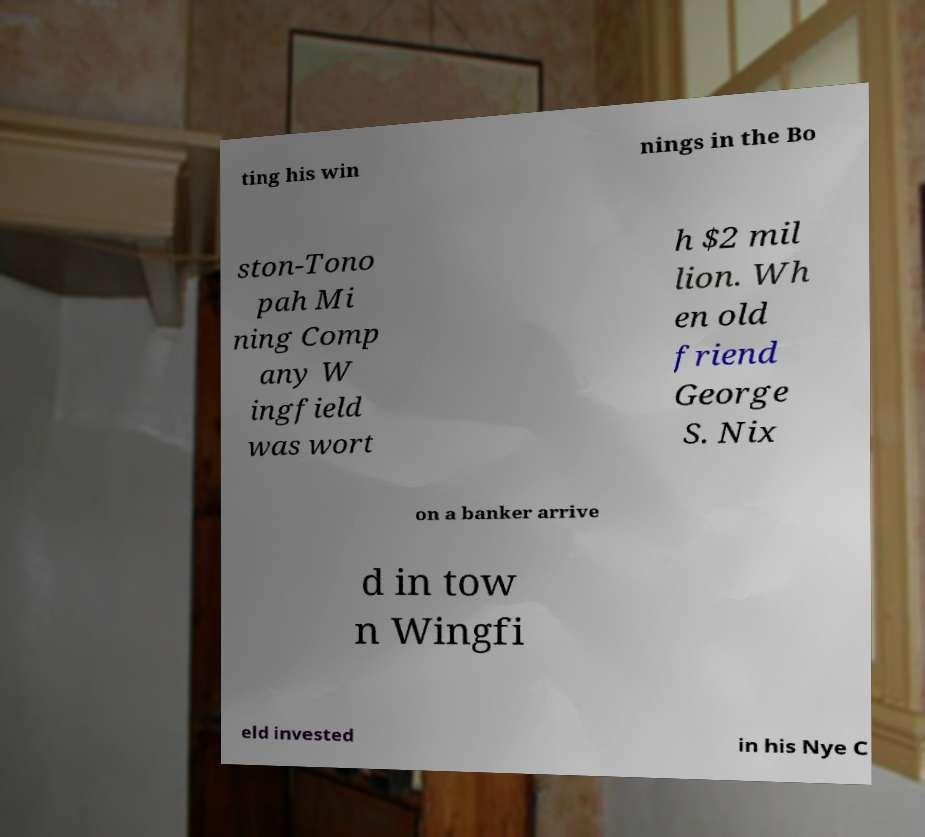I need the written content from this picture converted into text. Can you do that? ting his win nings in the Bo ston-Tono pah Mi ning Comp any W ingfield was wort h $2 mil lion. Wh en old friend George S. Nix on a banker arrive d in tow n Wingfi eld invested in his Nye C 